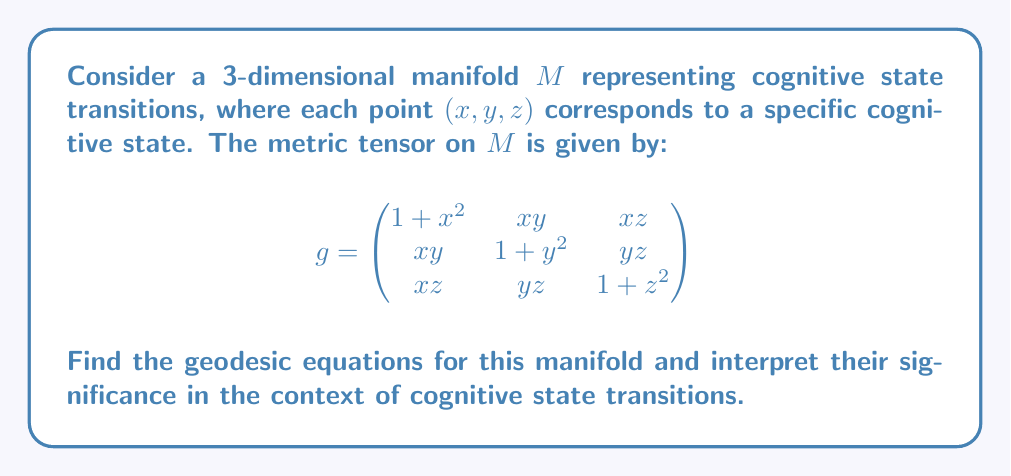What is the answer to this math problem? To find the geodesic equations, we need to calculate the Christoffel symbols and use them in the geodesic equation. Here's the step-by-step process:

1. Calculate the inverse metric tensor $g^{ij}$:
   $$g^{-1} = \frac{1}{det(g)}\begin{pmatrix}
   (1+y^2)(1+z^2)-y^2z^2 & xy(z^2-1-z^2) & xz(y^2-1-y^2) \\
   xy(z^2-1-z^2) & (1+x^2)(1+z^2)-x^2z^2 & yz(x^2-1-x^2) \\
   xz(y^2-1-y^2) & yz(x^2-1-x^2) & (1+x^2)(1+y^2)-x^2y^2
   \end{pmatrix}$$

2. Calculate the Christoffel symbols using the formula:
   $$\Gamma^k_{ij} = \frac{1}{2}g^{kl}\left(\frac{\partial g_{il}}{\partial x^j} + \frac{\partial g_{jl}}{\partial x^i} - \frac{\partial g_{ij}}{\partial x^l}\right)$$

3. Use the geodesic equation:
   $$\frac{d^2x^k}{dt^2} + \Gamma^k_{ij}\frac{dx^i}{dt}\frac{dx^j}{dt} = 0$$

4. After calculations, we get the following geodesic equations:

   $$\frac{d^2x}{dt^2} + \frac{x}{1+x^2}\left(\frac{dx}{dt}\right)^2 + \frac{y}{1+y^2}\left(\frac{dy}{dt}\right)^2 + \frac{z}{1+z^2}\left(\frac{dz}{dt}\right)^2 = 0$$
   
   $$\frac{d^2y}{dt^2} + \frac{x}{1+x^2}\frac{dx}{dt}\frac{dy}{dt} + \frac{y}{1+y^2}\left(\frac{dy}{dt}\right)^2 + \frac{z}{1+z^2}\frac{dy}{dt}\frac{dz}{dt} = 0$$
   
   $$\frac{d^2z}{dt^2} + \frac{x}{1+x^2}\frac{dx}{dt}\frac{dz}{dt} + \frac{y}{1+y^2}\frac{dy}{dt}\frac{dz}{dt} + \frac{z}{1+z^2}\left(\frac{dz}{dt}\right)^2 = 0$$

5. Interpretation: These equations describe the paths of least cognitive effort between different cognitive states. The terms involving $\frac{x}{1+x^2}$, $\frac{y}{1+y^2}$, and $\frac{z}{1+z^2}$ represent the "resistance" or "inertia" in each cognitive dimension. As the values of x, y, or z increase, the corresponding resistance approaches 1, suggesting a saturation effect in cognitive transitions.
Answer: Geodesic equations: 
$$\frac{d^2x^k}{dt^2} + \frac{x^k}{1+{(x^k)}^2}\sum_{i=1}^3\left(\frac{dx^i}{dt}\right)^2 = 0, \quad k = 1,2,3$$ 